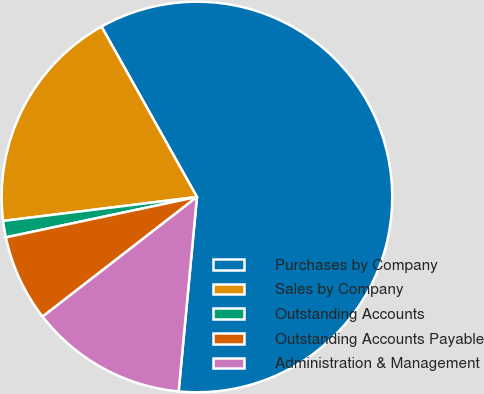<chart> <loc_0><loc_0><loc_500><loc_500><pie_chart><fcel>Purchases by Company<fcel>Sales by Company<fcel>Outstanding Accounts<fcel>Outstanding Accounts Payable<fcel>Administration & Management<nl><fcel>59.62%<fcel>18.83%<fcel>1.36%<fcel>7.18%<fcel>13.01%<nl></chart> 